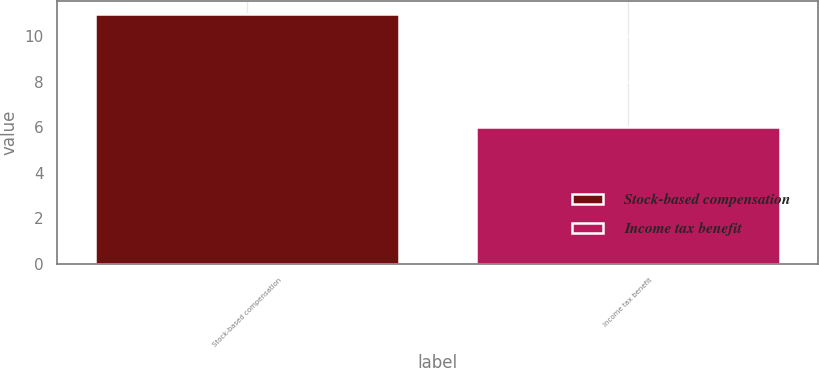<chart> <loc_0><loc_0><loc_500><loc_500><bar_chart><fcel>Stock-based compensation<fcel>Income tax benefit<nl><fcel>11<fcel>6<nl></chart> 